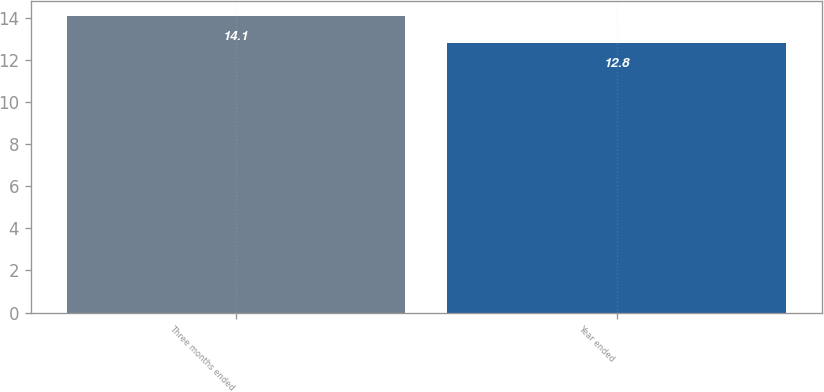Convert chart. <chart><loc_0><loc_0><loc_500><loc_500><bar_chart><fcel>Three months ended<fcel>Year ended<nl><fcel>14.1<fcel>12.8<nl></chart> 